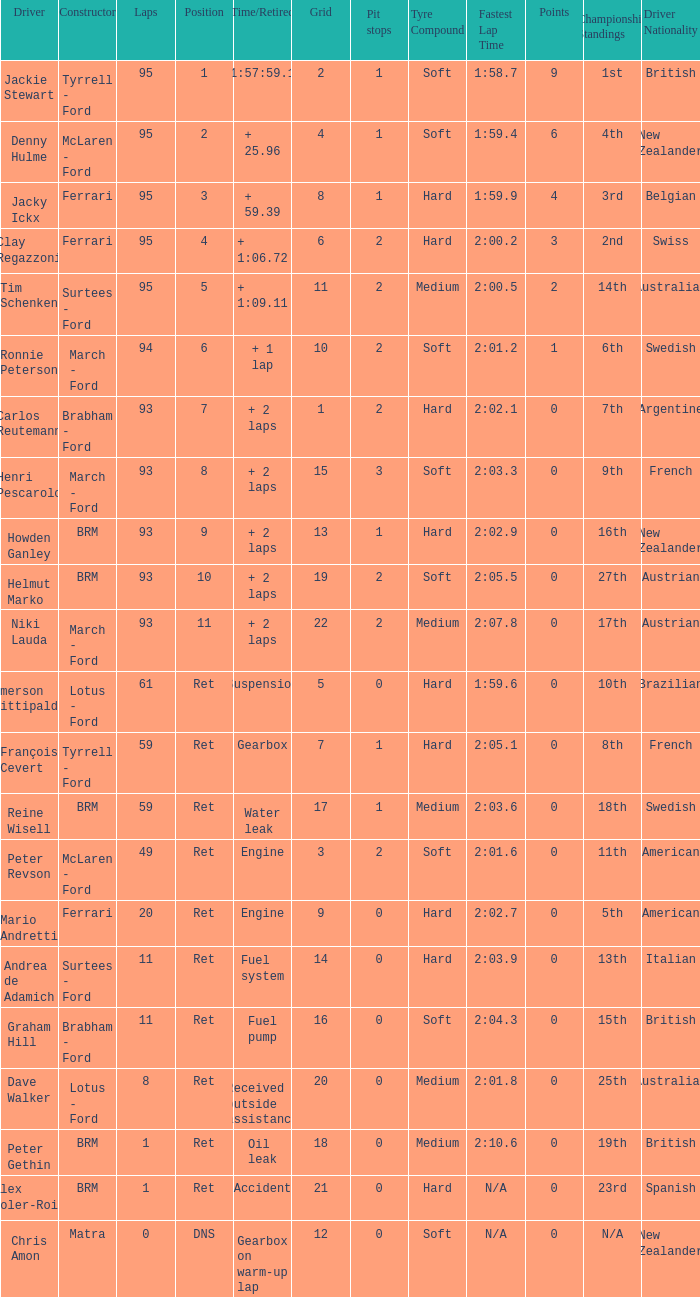Help me parse the entirety of this table. {'header': ['Driver', 'Constructor', 'Laps', 'Position', 'Time/Retired', 'Grid', 'Pit stops', 'Tyre Compound', 'Fastest Lap Time', 'Points', 'Championship Standings', 'Driver Nationality'], 'rows': [['Jackie Stewart', 'Tyrrell - Ford', '95', '1', '1:57:59.1', '2', '1', 'Soft', '1:58.7', '9', '1st', 'British'], ['Denny Hulme', 'McLaren - Ford', '95', '2', '+ 25.96', '4', '1', 'Soft', '1:59.4', '6', '4th', 'New Zealander'], ['Jacky Ickx', 'Ferrari', '95', '3', '+ 59.39', '8', '1', 'Hard', '1:59.9', '4', '3rd', 'Belgian'], ['Clay Regazzoni', 'Ferrari', '95', '4', '+ 1:06.72', '6', '2', 'Hard', '2:00.2', '3', '2nd', 'Swiss'], ['Tim Schenken', 'Surtees - Ford', '95', '5', '+ 1:09.11', '11', '2', 'Medium', '2:00.5', '2', '14th', 'Australian'], ['Ronnie Peterson', 'March - Ford', '94', '6', '+ 1 lap', '10', '2', 'Soft', '2:01.2', '1', '6th', 'Swedish'], ['Carlos Reutemann', 'Brabham - Ford', '93', '7', '+ 2 laps', '1', '2', 'Hard', '2:02.1', '0', '7th', 'Argentine'], ['Henri Pescarolo', 'March - Ford', '93', '8', '+ 2 laps', '15', '3', 'Soft', '2:03.3', '0', '9th', 'French'], ['Howden Ganley', 'BRM', '93', '9', '+ 2 laps', '13', '1', 'Hard', '2:02.9', '0', '16th', 'New Zealander'], ['Helmut Marko', 'BRM', '93', '10', '+ 2 laps', '19', '2', 'Soft', '2:05.5', '0', '27th', 'Austrian'], ['Niki Lauda', 'March - Ford', '93', '11', '+ 2 laps', '22', '2', 'Medium', '2:07.8', '0', '17th', 'Austrian'], ['Emerson Fittipaldi', 'Lotus - Ford', '61', 'Ret', 'Suspension', '5', '0', 'Hard', '1:59.6', '0', '10th', 'Brazilian'], ['François Cevert', 'Tyrrell - Ford', '59', 'Ret', 'Gearbox', '7', '1', 'Hard', '2:05.1', '0', '8th', 'French'], ['Reine Wisell', 'BRM', '59', 'Ret', 'Water leak', '17', '1', 'Medium', '2:03.6', '0', '18th', 'Swedish'], ['Peter Revson', 'McLaren - Ford', '49', 'Ret', 'Engine', '3', '2', 'Soft', '2:01.6', '0', '11th', 'American'], ['Mario Andretti', 'Ferrari', '20', 'Ret', 'Engine', '9', '0', 'Hard', '2:02.7', '0', '5th', 'American'], ['Andrea de Adamich', 'Surtees - Ford', '11', 'Ret', 'Fuel system', '14', '0', 'Hard', '2:03.9', '0', '13th', 'Italian'], ['Graham Hill', 'Brabham - Ford', '11', 'Ret', 'Fuel pump', '16', '0', 'Soft', '2:04.3', '0', '15th', 'British'], ['Dave Walker', 'Lotus - Ford', '8', 'Ret', 'Received outside assistance', '20', '0', 'Medium', '2:01.8', '0', '25th', 'Australian'], ['Peter Gethin', 'BRM', '1', 'Ret', 'Oil leak', '18', '0', 'Medium', '2:10.6', '0', '19th', 'British'], ['Alex Soler-Roig', 'BRM', '1', 'Ret', 'Accident', '21', '0', 'Hard', 'N/A', '0', '23rd', 'Spanish'], ['Chris Amon', 'Matra', '0', 'DNS', 'Gearbox on warm-up lap', '12', '0', 'Soft', 'N/A', '0', 'N/A', 'New Zealander']]} What is the sum of grids that peter gethin has? 18.0. 